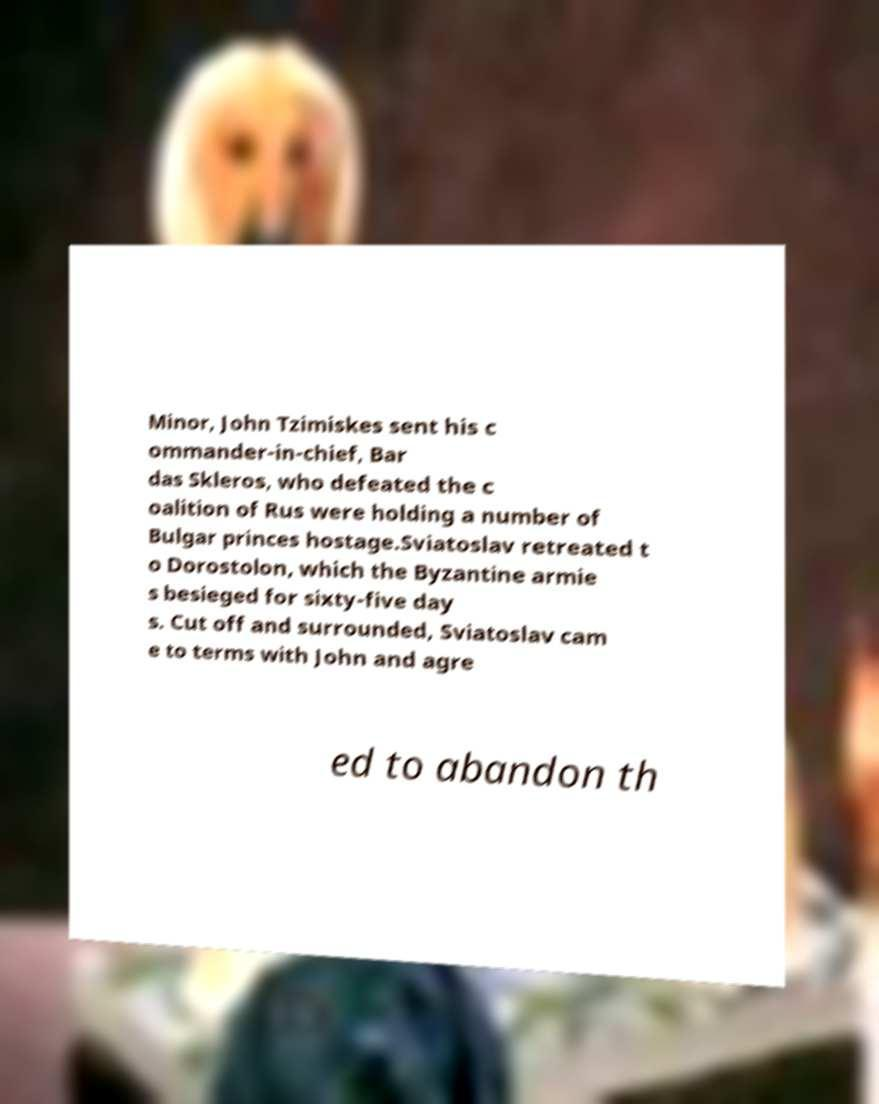I need the written content from this picture converted into text. Can you do that? Minor, John Tzimiskes sent his c ommander-in-chief, Bar das Skleros, who defeated the c oalition of Rus were holding a number of Bulgar princes hostage.Sviatoslav retreated t o Dorostolon, which the Byzantine armie s besieged for sixty-five day s. Cut off and surrounded, Sviatoslav cam e to terms with John and agre ed to abandon th 